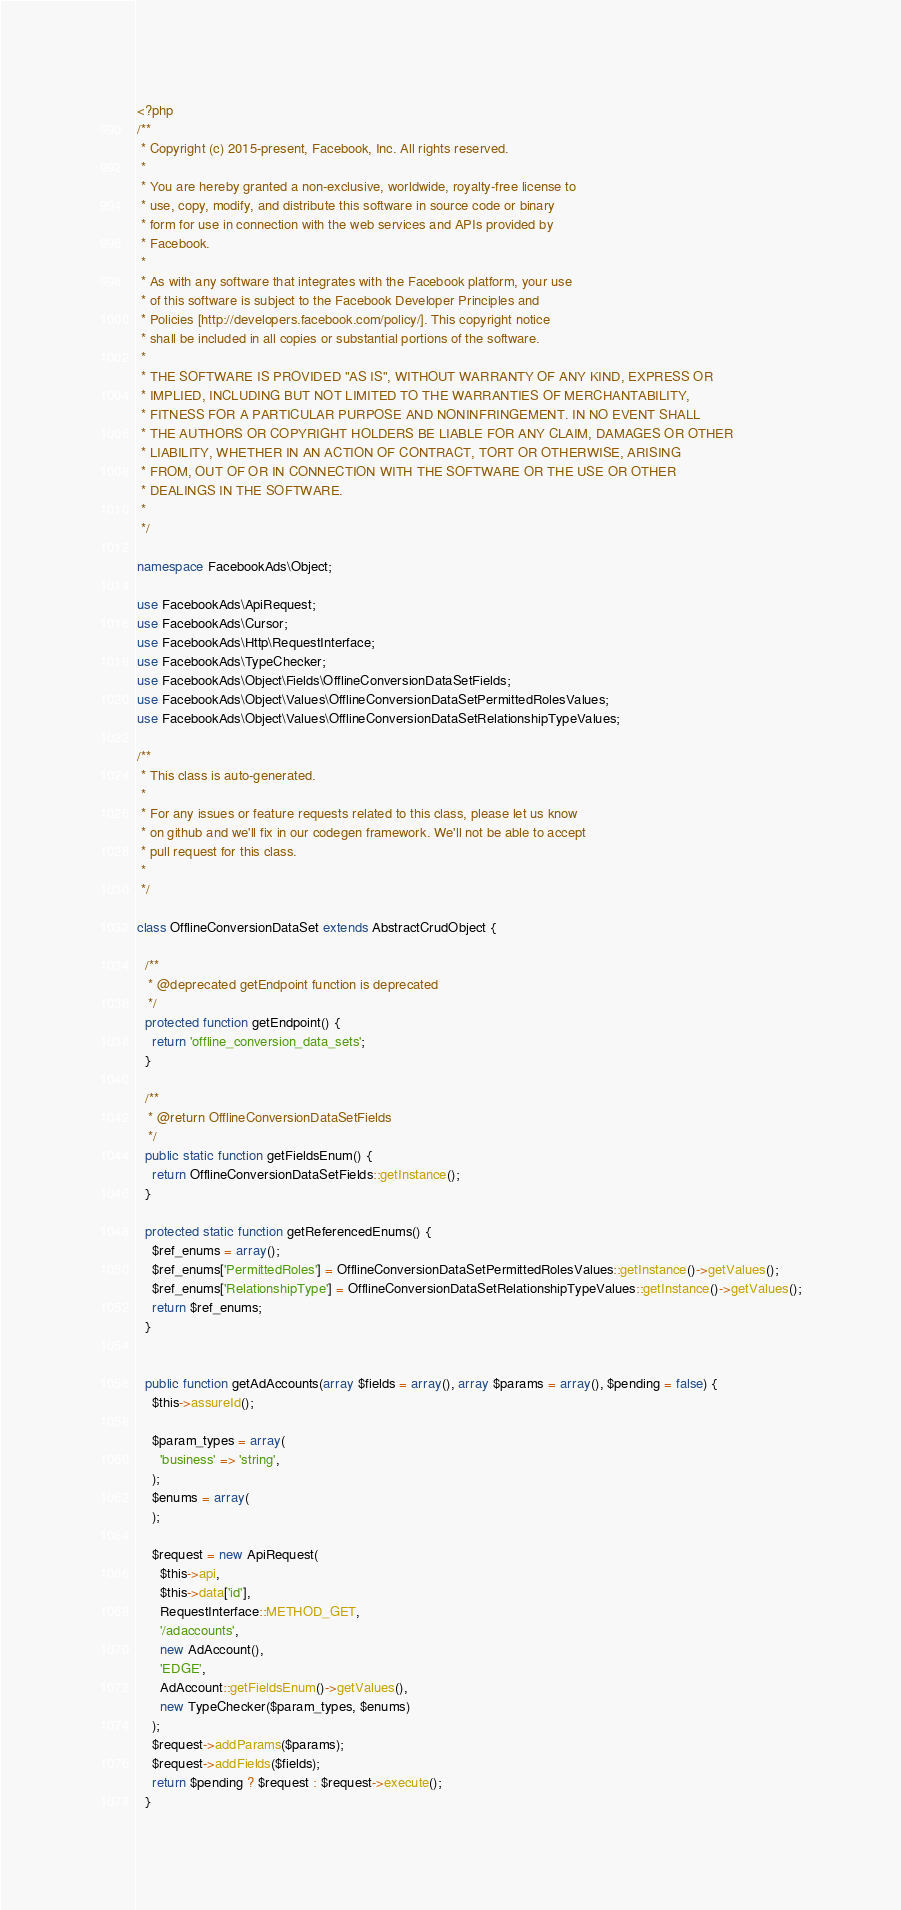Convert code to text. <code><loc_0><loc_0><loc_500><loc_500><_PHP_><?php
/**
 * Copyright (c) 2015-present, Facebook, Inc. All rights reserved.
 *
 * You are hereby granted a non-exclusive, worldwide, royalty-free license to
 * use, copy, modify, and distribute this software in source code or binary
 * form for use in connection with the web services and APIs provided by
 * Facebook.
 *
 * As with any software that integrates with the Facebook platform, your use
 * of this software is subject to the Facebook Developer Principles and
 * Policies [http://developers.facebook.com/policy/]. This copyright notice
 * shall be included in all copies or substantial portions of the software.
 *
 * THE SOFTWARE IS PROVIDED "AS IS", WITHOUT WARRANTY OF ANY KIND, EXPRESS OR
 * IMPLIED, INCLUDING BUT NOT LIMITED TO THE WARRANTIES OF MERCHANTABILITY,
 * FITNESS FOR A PARTICULAR PURPOSE AND NONINFRINGEMENT. IN NO EVENT SHALL
 * THE AUTHORS OR COPYRIGHT HOLDERS BE LIABLE FOR ANY CLAIM, DAMAGES OR OTHER
 * LIABILITY, WHETHER IN AN ACTION OF CONTRACT, TORT OR OTHERWISE, ARISING
 * FROM, OUT OF OR IN CONNECTION WITH THE SOFTWARE OR THE USE OR OTHER
 * DEALINGS IN THE SOFTWARE.
 *
 */

namespace FacebookAds\Object;

use FacebookAds\ApiRequest;
use FacebookAds\Cursor;
use FacebookAds\Http\RequestInterface;
use FacebookAds\TypeChecker;
use FacebookAds\Object\Fields\OfflineConversionDataSetFields;
use FacebookAds\Object\Values\OfflineConversionDataSetPermittedRolesValues;
use FacebookAds\Object\Values\OfflineConversionDataSetRelationshipTypeValues;

/**
 * This class is auto-generated.
 *
 * For any issues or feature requests related to this class, please let us know
 * on github and we'll fix in our codegen framework. We'll not be able to accept
 * pull request for this class.
 *
 */

class OfflineConversionDataSet extends AbstractCrudObject {

  /**
   * @deprecated getEndpoint function is deprecated
   */
  protected function getEndpoint() {
    return 'offline_conversion_data_sets';
  }

  /**
   * @return OfflineConversionDataSetFields
   */
  public static function getFieldsEnum() {
    return OfflineConversionDataSetFields::getInstance();
  }

  protected static function getReferencedEnums() {
    $ref_enums = array();
    $ref_enums['PermittedRoles'] = OfflineConversionDataSetPermittedRolesValues::getInstance()->getValues();
    $ref_enums['RelationshipType'] = OfflineConversionDataSetRelationshipTypeValues::getInstance()->getValues();
    return $ref_enums;
  }


  public function getAdAccounts(array $fields = array(), array $params = array(), $pending = false) {
    $this->assureId();

    $param_types = array(
      'business' => 'string',
    );
    $enums = array(
    );

    $request = new ApiRequest(
      $this->api,
      $this->data['id'],
      RequestInterface::METHOD_GET,
      '/adaccounts',
      new AdAccount(),
      'EDGE',
      AdAccount::getFieldsEnum()->getValues(),
      new TypeChecker($param_types, $enums)
    );
    $request->addParams($params);
    $request->addFields($fields);
    return $pending ? $request : $request->execute();
  }
</code> 